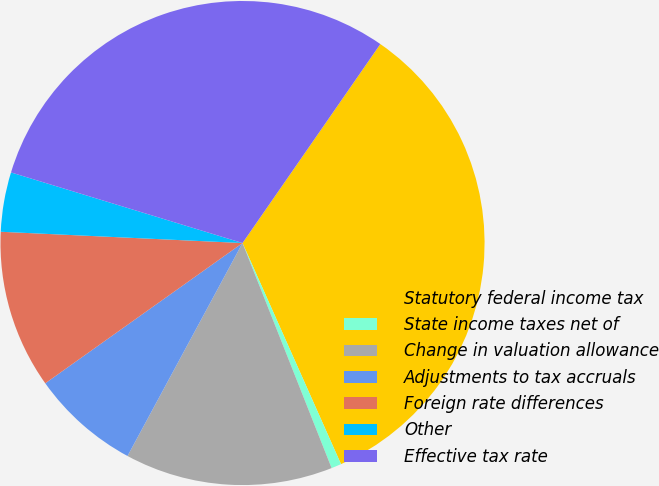<chart> <loc_0><loc_0><loc_500><loc_500><pie_chart><fcel>Statutory federal income tax<fcel>State income taxes net of<fcel>Change in valuation allowance<fcel>Adjustments to tax accruals<fcel>Foreign rate differences<fcel>Other<fcel>Effective tax rate<nl><fcel>33.69%<fcel>0.67%<fcel>13.88%<fcel>7.28%<fcel>10.58%<fcel>3.97%<fcel>29.93%<nl></chart> 